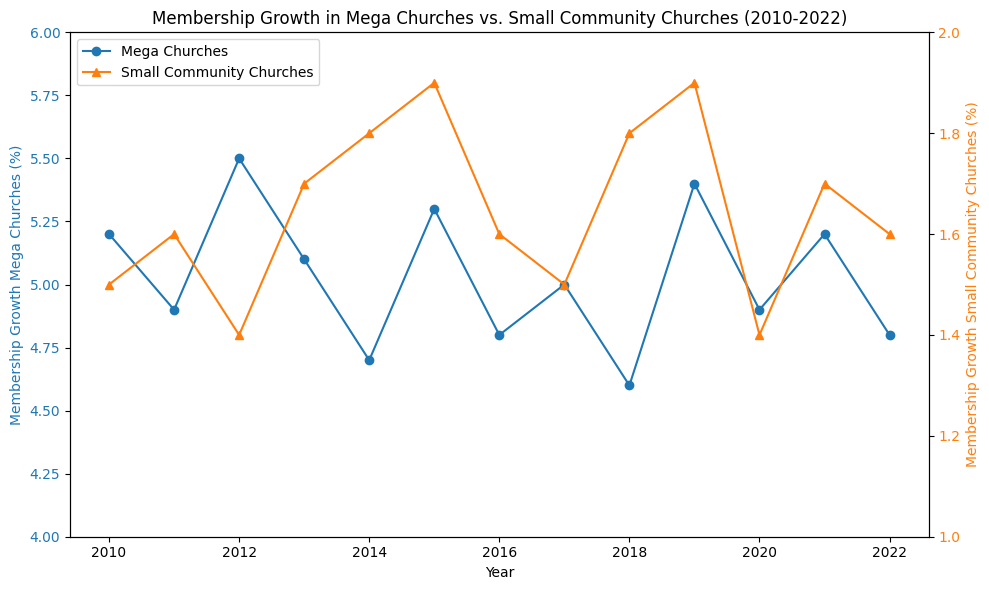What's the average membership growth in Mega Churches from 2010 to 2022? The membership growth percentages from 2010 to 2022 for Mega Churches are given. Summing these and dividing by the number of years: (5.2 + 4.9 + 5.5 + 5.1 + 4.7 + 5.3 + 4.8 + 5.0 + 4.6 + 5.4 + 4.9 + 5.2 + 4.8) / 13. The sum is 65.4, hence the average is 65.4 / 13
Answer: 5.03 Which year shows the highest membership growth in Mega Churches and what's the percentage? According to the data, the highest membership growth in Mega Churches occurs in 2012 with a percentage of 5.5%
Answer: 2012, 5.5% Which year shows the lowest membership growth in Small Community Churches? Observing the percentages for Small Community Churches, the lowest growth is in 2012 and 2020, both with 1.4%
Answer: 2012, 2020 In which year is the difference between the membership growth of Mega Churches and Small Community Churches the largest? To find this, we calculate the yearly differences and identify the maximum. The calculated differences are: 3.7 (2010), 3.3 (2011), 4.1 (2012), 3.4 (2013), 2.9 (2014), 3.4 (2015), 3.2 (2016), 3.5 (2017), 2.8 (2018), 3.5 (2019), 3.5 (2020), 3.5 (2021), and 3.2 (2022). The largest difference is in 2012 with 4.1%
Answer: 2012 How many years saw an increase in membership growth in Small Community Churches compared to the previous year? Compare each year's data with the prior year's to determine the increases: 2011 > 2010, 2013 > 2012, 2014 > 2013, 2015 > 2014, 2018 > 2017. There are 5 years with increases
Answer: 5 What's the average membership growth in Small Community Churches from 2010 to 2022? The membership growth percentages from 2010 to 2022 for Small Community Churches are given. Summing these and dividing by the number of years: (1.5 + 1.6 + 1.4 + 1.7 + 1.8 + 1.9 + 1.6 + 1.5 + 1.8 + 1.9 + 1.4 + 1.7 + 1.6) / 13. The sum is 21.4, hence the average is 21.4 / 13
Answer: 1.65 Compare the overall trend in membership growth for Mega Churches vs. Small Community Churches from 2010 to 2022. The trend lines must be assessed: Mega Churches see fluctuations around 5% with slight decreases and a few peaks, while Small Community Churches consistently grow at a steady but low rate around 1.6%. Mega Churches exhibit more variability, while Small Community Churches show a more stable and gradual increase
Answer: Mega Churches: variable, Small Community Churches: steady growth In which year did Mega Churches and Small Community Churches both experience the same membership growth as their previous year? Verify the data for each year where the growth is the same as the prior year. No data points meet this criterion; each year shows a different value when compared to the preceding year
Answer: None 